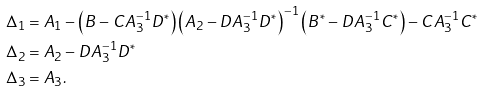Convert formula to latex. <formula><loc_0><loc_0><loc_500><loc_500>\Delta _ { 1 } & = A _ { 1 } - \left ( B - C A _ { 3 } ^ { - 1 } D ^ { * } \right ) \left ( A _ { 2 } - D A _ { 3 } ^ { - 1 } D ^ { * } \right ) ^ { - 1 } \left ( B ^ { * } - D A _ { 3 } ^ { - 1 } C ^ { * } \right ) - C A _ { 3 } ^ { - 1 } C ^ { * } \\ \Delta _ { 2 } & = A _ { 2 } - D A _ { 3 } ^ { - 1 } D ^ { * } \\ \Delta _ { 3 } & = A _ { 3 } .</formula> 